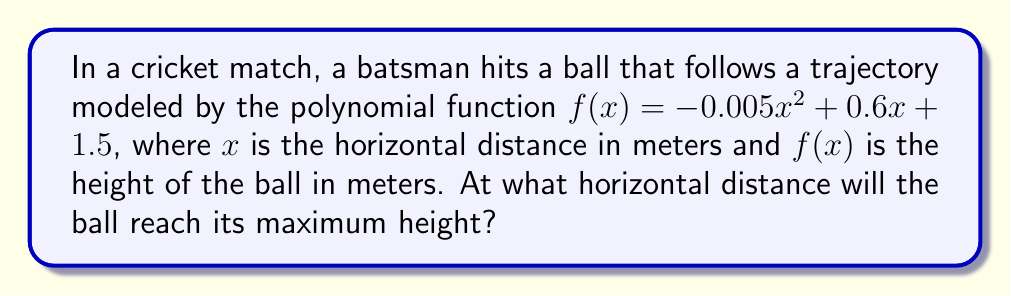Solve this math problem. To find the horizontal distance at which the ball reaches its maximum height, we need to follow these steps:

1) The given polynomial function is of the form $f(x) = ax^2 + bx + c$, where:
   $a = -0.005$
   $b = 0.6$
   $c = 1.5$

2) For a quadratic function, the x-coordinate of the vertex represents the point where the function reaches its maximum (if $a < 0$) or minimum (if $a > 0$).

3) The formula for the x-coordinate of the vertex is: $x = -\frac{b}{2a}$

4) Substituting our values:
   $x = -\frac{0.6}{2(-0.005)}$

5) Simplifying:
   $x = -\frac{0.6}{-0.01} = 60$

Therefore, the ball will reach its maximum height when the horizontal distance is 60 meters.
Answer: 60 meters 